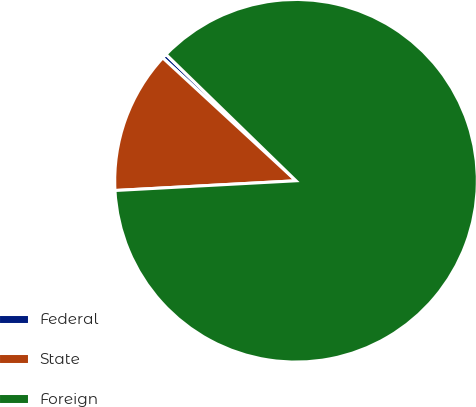Convert chart to OTSL. <chart><loc_0><loc_0><loc_500><loc_500><pie_chart><fcel>Federal<fcel>State<fcel>Foreign<nl><fcel>0.42%<fcel>12.71%<fcel>86.86%<nl></chart> 